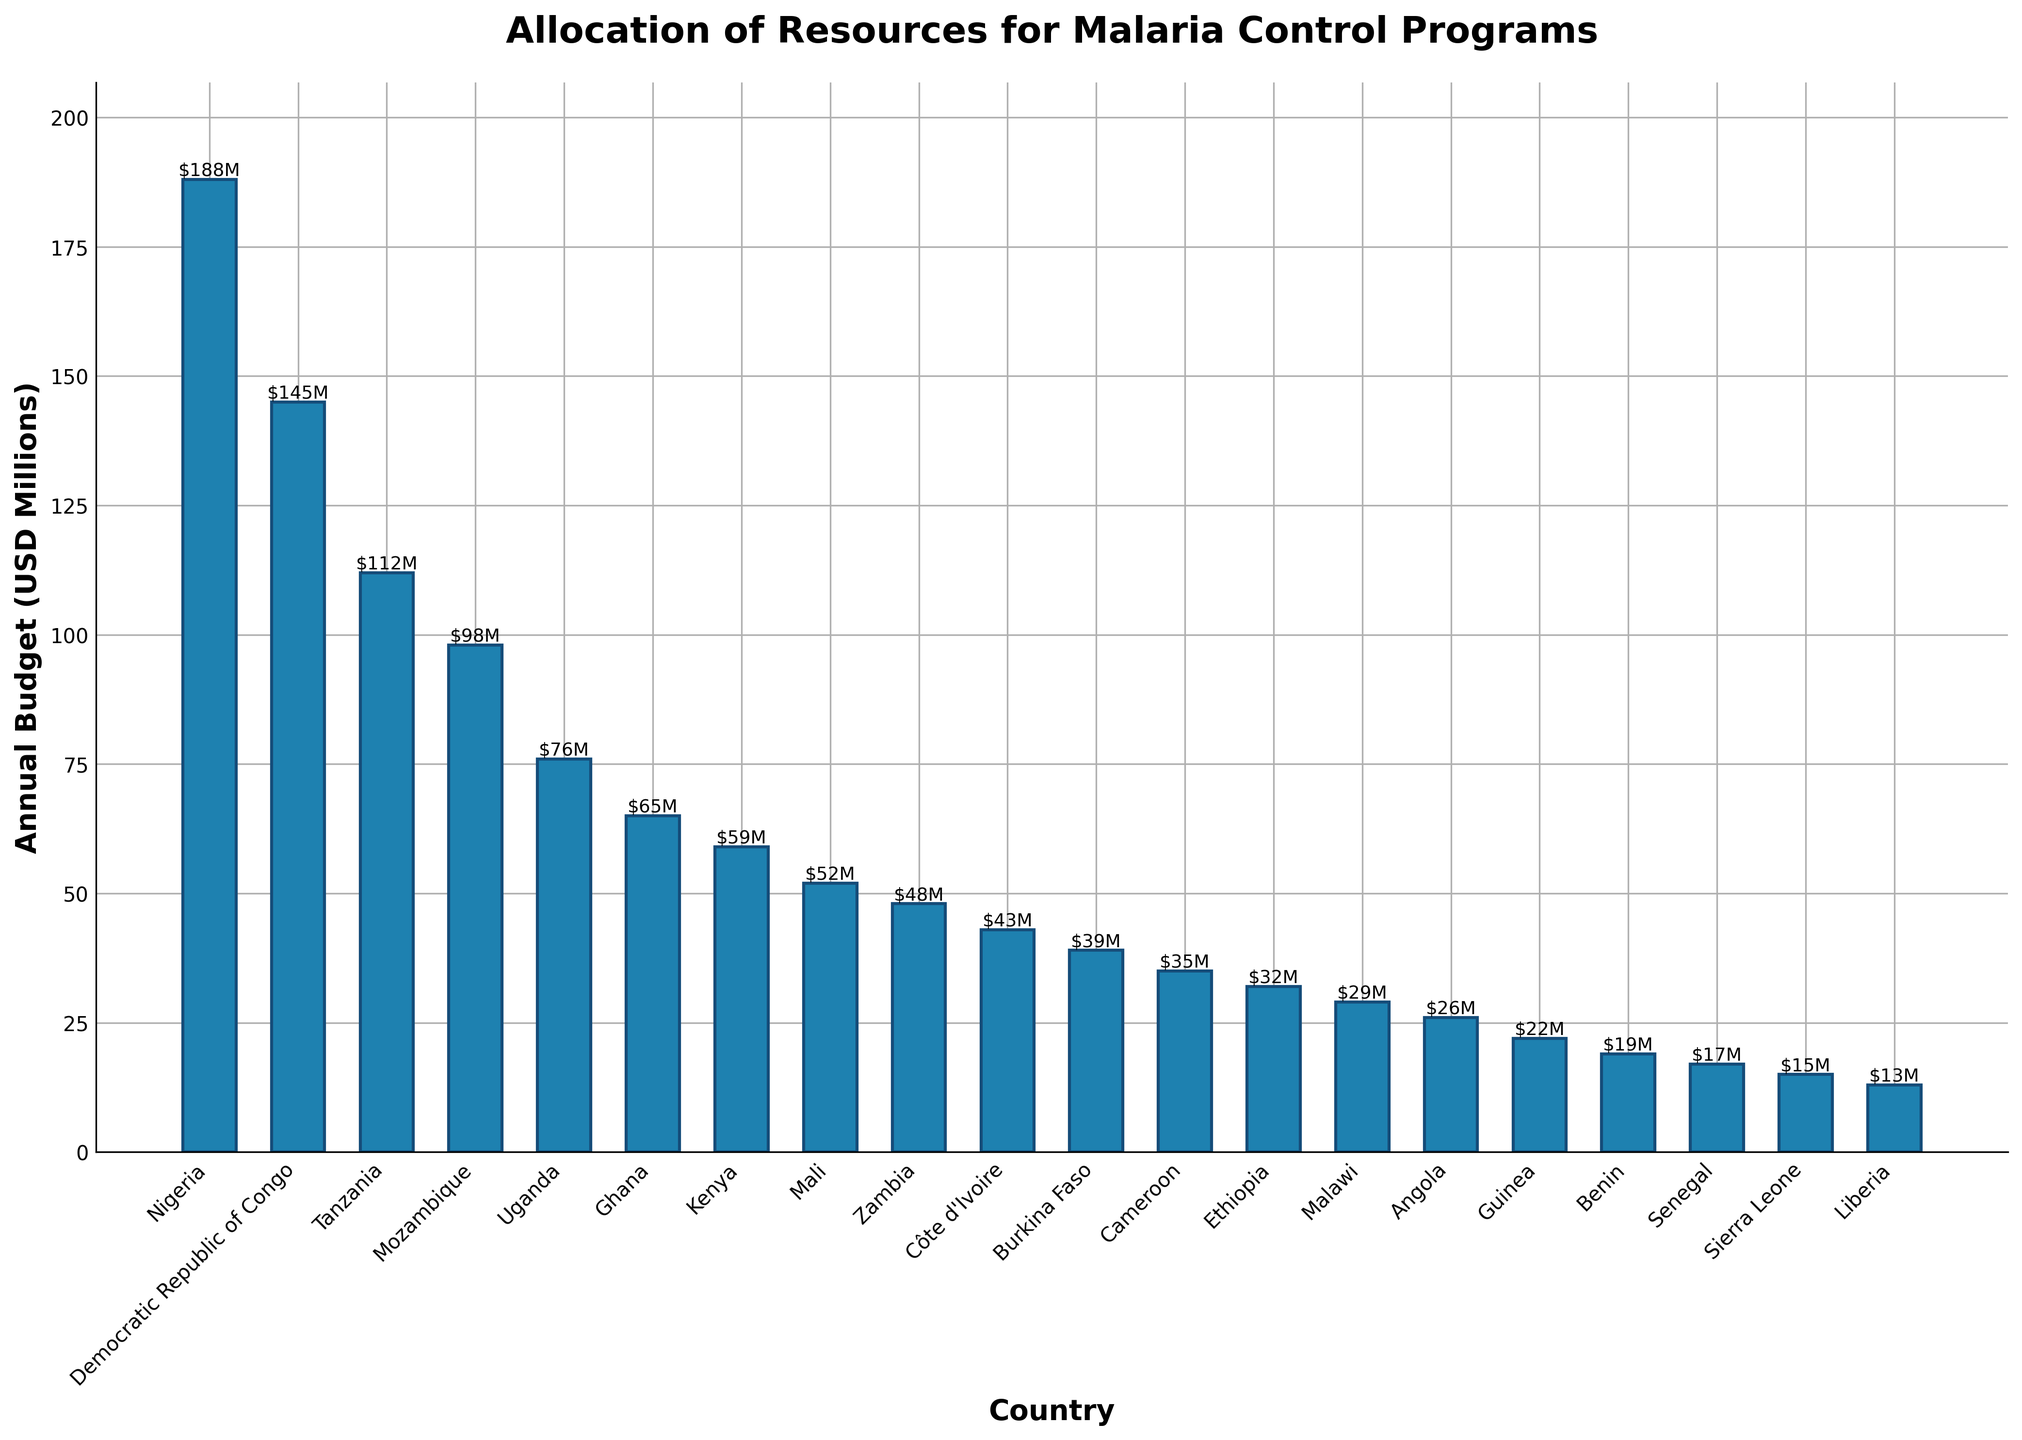Which country has the highest annual budget for malaria control programs? The bar with the greatest height represents the country with the highest budget. Nigeria has the tallest bar.
Answer: Nigeria What is the combined annual budget of Mozambique and Uganda? Locate the bars for Mozambique and Uganda, then add their budget values: 98 + 76 = 174.
Answer: 174 Which countries have annual budgets less than 50 million USD? Inspect the bars and identify those with heights corresponding to values less than 50 million USD. These countries are Zambia, Côte d'Ivoire, Burkina Faso, Cameroon, Ethiopia, Malawi, Angola, Guinea, Benin, Senegal, Sierra Leone, and Liberia.
Answer: Zambia, Côte d'Ivoire, Burkina Faso, Cameroon, Ethiopia, Malawi, Angola, Guinea, Benin, Senegal, Sierra Leone, Liberia What is the average annual budget of the top 5 countries? The top 5 countries by budget are Nigeria, Democratic Republic of Congo, Tanzania, Mozambique, and Uganda. Calculate their average: (188 + 145 + 112 + 98 + 76) / 5 = 123.8.
Answer: 123.8 How much higher is the annual budget of the country with the highest budget compared to the country with the lowest? The highest budget is Nigeria with 188 million USD, and the lowest is Liberia with 13 million USD. Calculate the difference: 188 - 13 = 175.
Answer: 175 Which countries have similar budgets to Ghana? Ghana has an annual budget of 65 million USD. Countries with close budget values are Kenya (59 million USD) and Uganda (76 million USD).
Answer: Kenya, Uganda What is the total budget allocated across all the countries? Add up the budgets of all countries: 188 + 145 + 112 + 98 + 76 + 65 + 59 + 52 + 48 + 43 + 39 + 35 + 32 + 29 + 26 + 22 + 19 + 17 + 15 + 13 = 1,136.
Answer: 1,136 Which country has an annual budget closest to 30 million USD? Examine the bars around the 30 million USD mark. Ethiopia has a budget of 32 million USD, which is the closest.
Answer: Ethiopia 